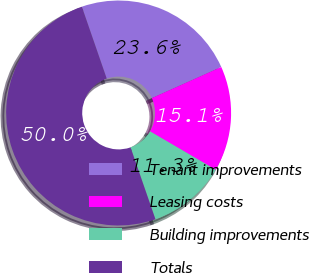Convert chart to OTSL. <chart><loc_0><loc_0><loc_500><loc_500><pie_chart><fcel>Tenant improvements<fcel>Leasing costs<fcel>Building improvements<fcel>Totals<nl><fcel>23.59%<fcel>15.14%<fcel>11.26%<fcel>50.0%<nl></chart> 